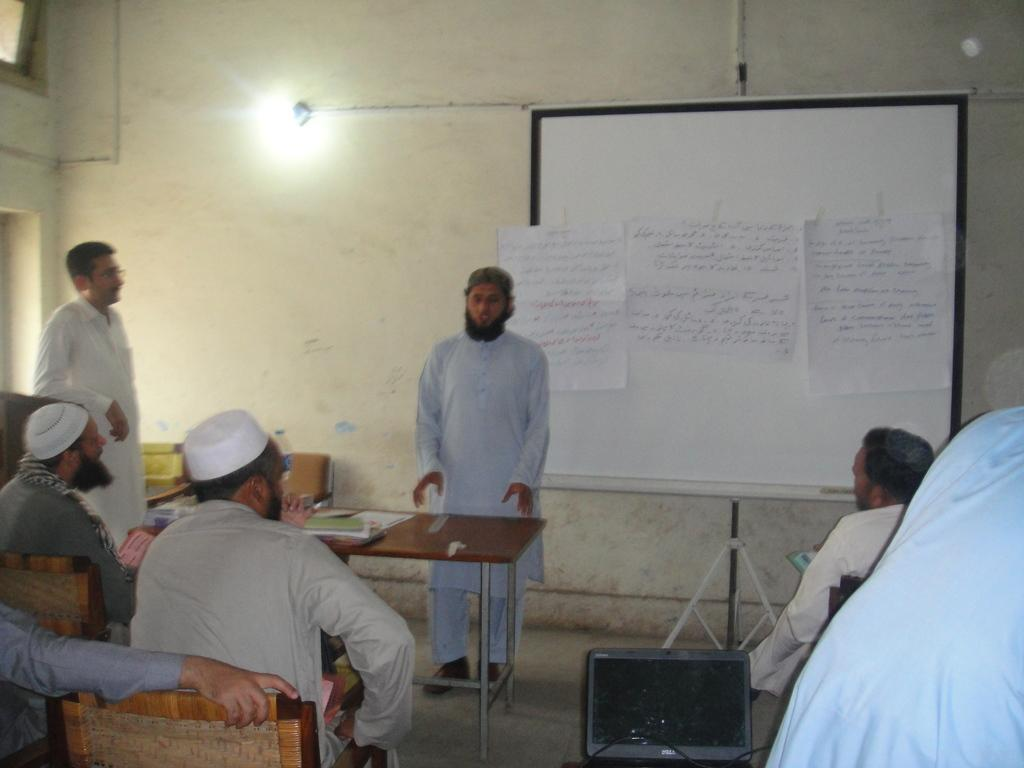What are the people in the image doing? There are people sitting and standing in the image. What activity is being performed with the papers in the image? Papers are passed to a board in the image. What can be seen on the table in the image? There are objects on a table in the image. Can you tell me how many roses are on the table in the image? There is no rose present on the table in the image. What type of monkey can be seen interacting with the people in the image? There is no monkey present in the image; it only features people. 